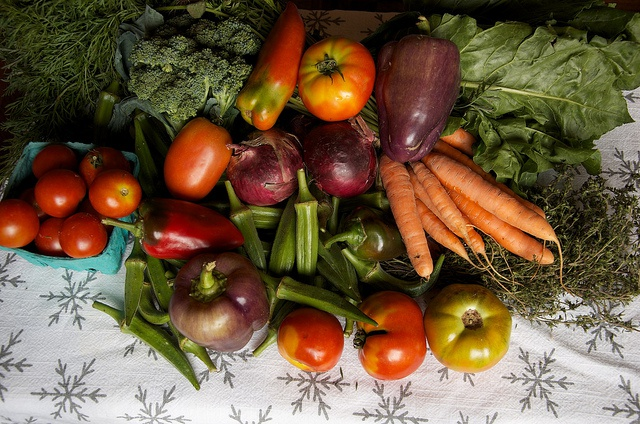Describe the objects in this image and their specific colors. I can see carrot in black, orange, red, brown, and maroon tones and broccoli in black, darkgreen, and olive tones in this image. 